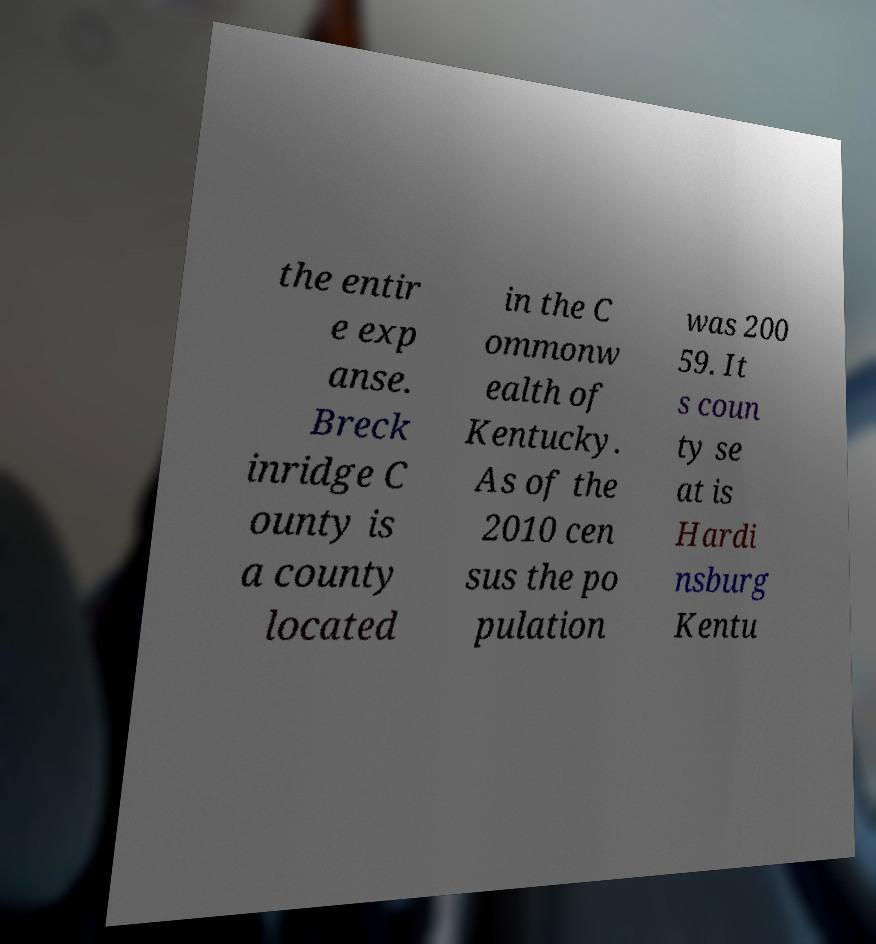Please read and relay the text visible in this image. What does it say? the entir e exp anse. Breck inridge C ounty is a county located in the C ommonw ealth of Kentucky. As of the 2010 cen sus the po pulation was 200 59. It s coun ty se at is Hardi nsburg Kentu 